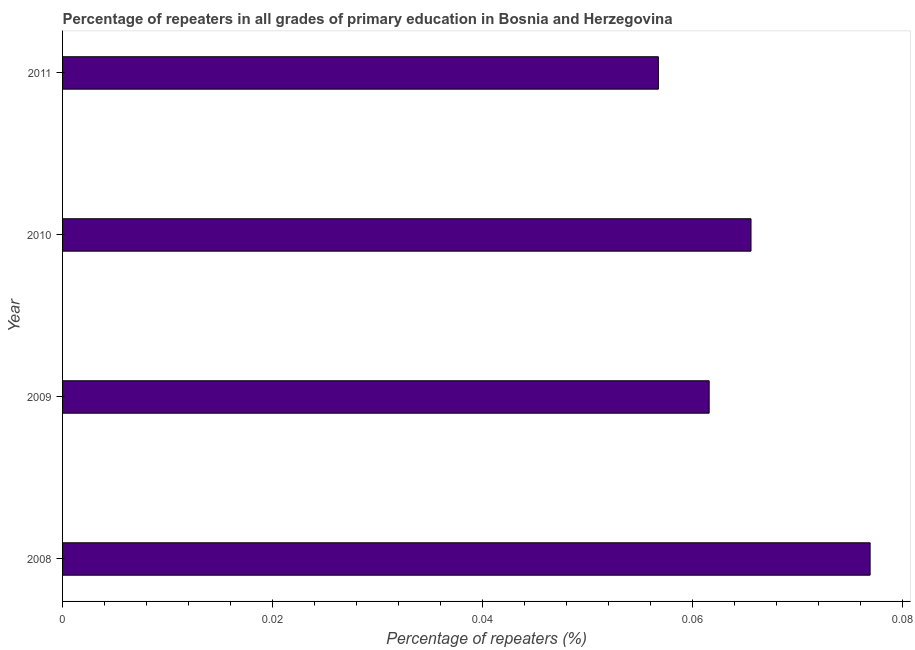Does the graph contain any zero values?
Your response must be concise. No. What is the title of the graph?
Your answer should be compact. Percentage of repeaters in all grades of primary education in Bosnia and Herzegovina. What is the label or title of the X-axis?
Provide a short and direct response. Percentage of repeaters (%). What is the percentage of repeaters in primary education in 2009?
Ensure brevity in your answer.  0.06. Across all years, what is the maximum percentage of repeaters in primary education?
Give a very brief answer. 0.08. Across all years, what is the minimum percentage of repeaters in primary education?
Your answer should be very brief. 0.06. In which year was the percentage of repeaters in primary education maximum?
Provide a succinct answer. 2008. What is the sum of the percentage of repeaters in primary education?
Your answer should be compact. 0.26. What is the difference between the percentage of repeaters in primary education in 2009 and 2011?
Your response must be concise. 0.01. What is the average percentage of repeaters in primary education per year?
Provide a short and direct response. 0.07. What is the median percentage of repeaters in primary education?
Offer a terse response. 0.06. In how many years, is the percentage of repeaters in primary education greater than 0.008 %?
Your answer should be compact. 4. What is the ratio of the percentage of repeaters in primary education in 2008 to that in 2011?
Your answer should be very brief. 1.35. What is the difference between the highest and the second highest percentage of repeaters in primary education?
Offer a very short reply. 0.01. Are all the bars in the graph horizontal?
Offer a very short reply. Yes. What is the Percentage of repeaters (%) in 2008?
Your response must be concise. 0.08. What is the Percentage of repeaters (%) in 2009?
Your response must be concise. 0.06. What is the Percentage of repeaters (%) of 2010?
Provide a short and direct response. 0.07. What is the Percentage of repeaters (%) in 2011?
Make the answer very short. 0.06. What is the difference between the Percentage of repeaters (%) in 2008 and 2009?
Offer a terse response. 0.02. What is the difference between the Percentage of repeaters (%) in 2008 and 2010?
Make the answer very short. 0.01. What is the difference between the Percentage of repeaters (%) in 2008 and 2011?
Give a very brief answer. 0.02. What is the difference between the Percentage of repeaters (%) in 2009 and 2010?
Your answer should be very brief. -0. What is the difference between the Percentage of repeaters (%) in 2009 and 2011?
Your answer should be very brief. 0. What is the difference between the Percentage of repeaters (%) in 2010 and 2011?
Ensure brevity in your answer.  0.01. What is the ratio of the Percentage of repeaters (%) in 2008 to that in 2009?
Offer a very short reply. 1.25. What is the ratio of the Percentage of repeaters (%) in 2008 to that in 2010?
Offer a very short reply. 1.17. What is the ratio of the Percentage of repeaters (%) in 2008 to that in 2011?
Ensure brevity in your answer.  1.35. What is the ratio of the Percentage of repeaters (%) in 2009 to that in 2010?
Your response must be concise. 0.94. What is the ratio of the Percentage of repeaters (%) in 2009 to that in 2011?
Offer a terse response. 1.08. What is the ratio of the Percentage of repeaters (%) in 2010 to that in 2011?
Ensure brevity in your answer.  1.16. 